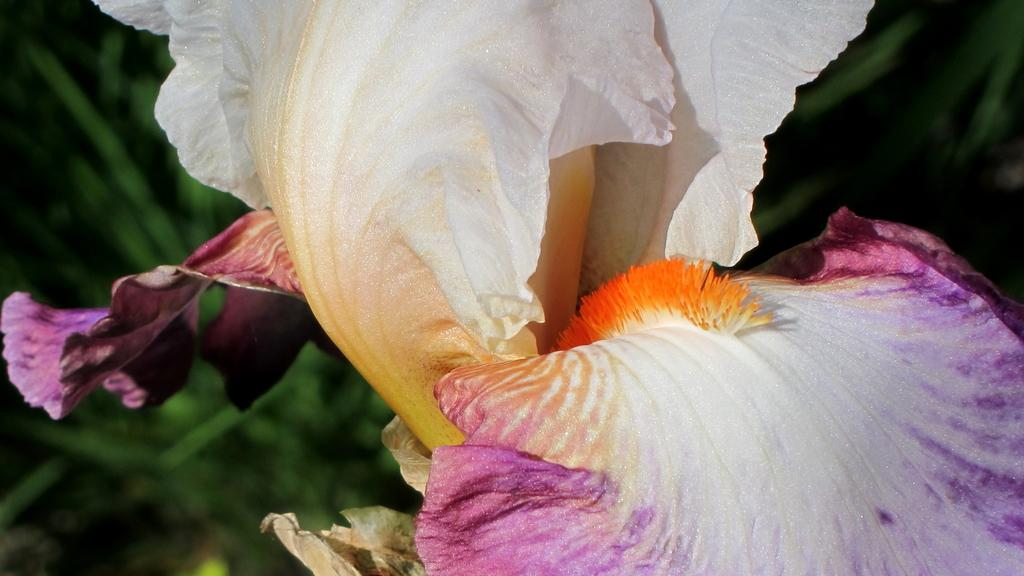What type of object is present in the image? There are flower petals in the image. Can you describe the colors of the flower petals? The flower petals are white and violet in color. What color is the background of the image? The background of the image is green in color. What type of representative can be seen sitting on the sofa in the image? There is no representative or sofa present in the image; it only features flower petals and a green background. 